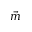Convert formula to latex. <formula><loc_0><loc_0><loc_500><loc_500>\vec { m }</formula> 